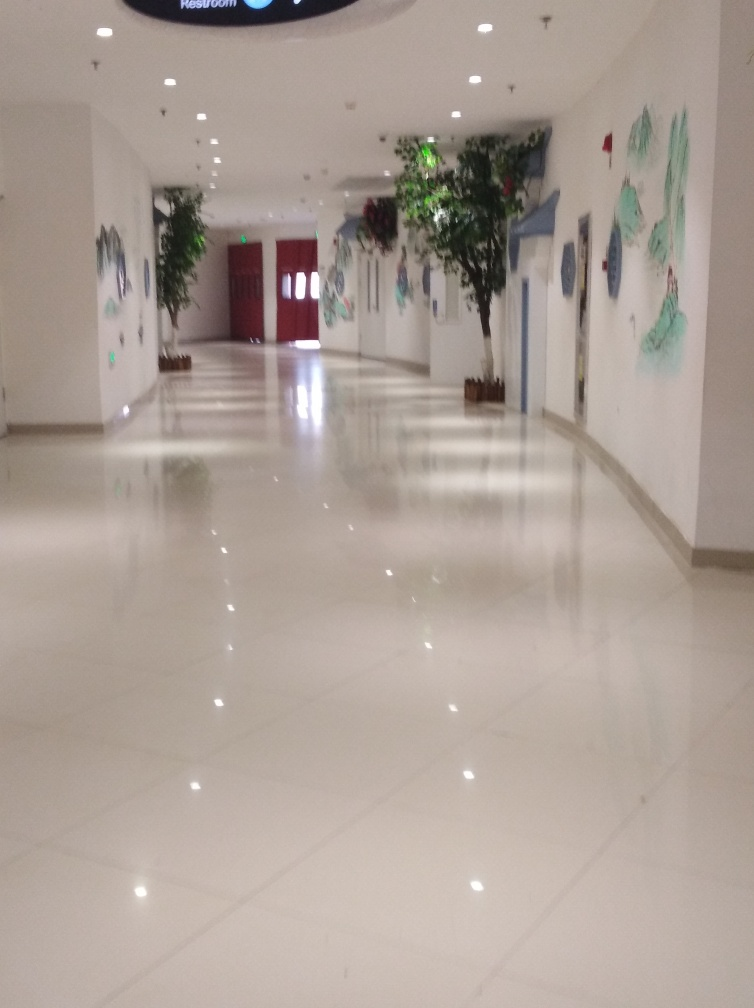How could this space be used, judging by the image? Judging by the cleanliness, the openness, and the decor, this space appears to be an atrium or hallway within perhaps a corporate building, art gallery, or hotel. The presence of artwork on the walls and the lack of furniture suggest it could be a transitional area meant for passing through, while offering a visually pleasing experience to those who walk by. 